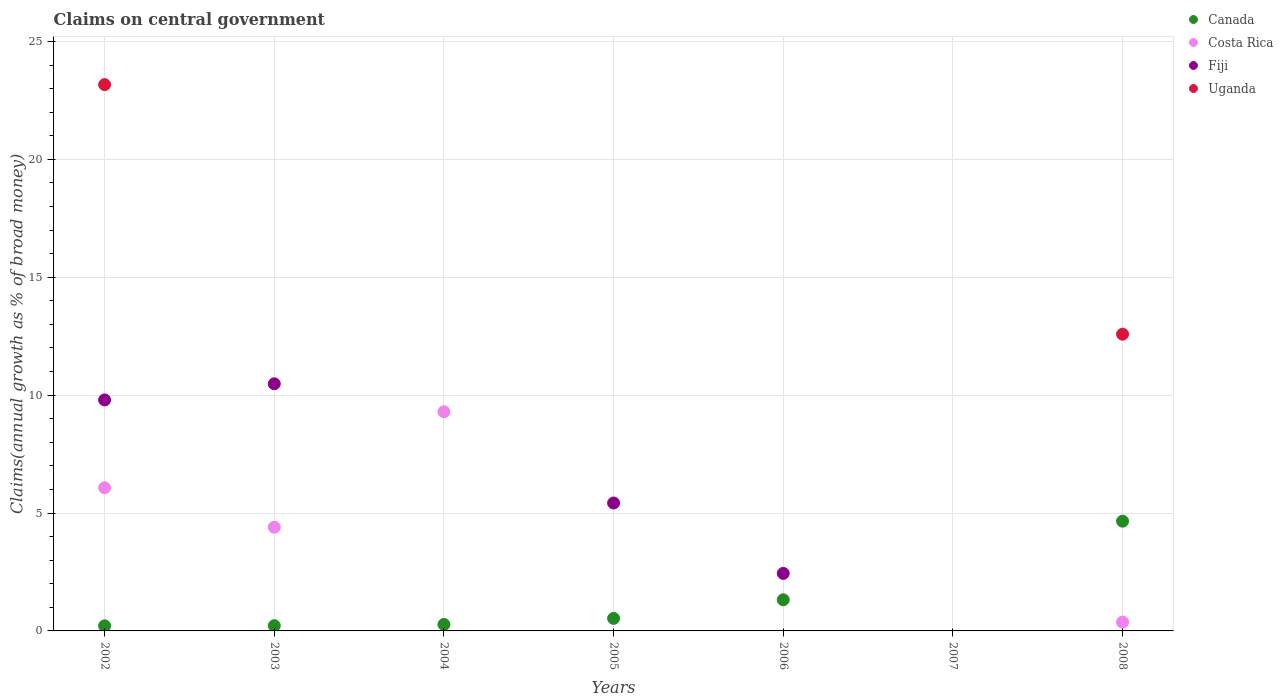How many different coloured dotlines are there?
Offer a very short reply. 4. What is the percentage of broad money claimed on centeral government in Costa Rica in 2003?
Give a very brief answer. 4.4. Across all years, what is the maximum percentage of broad money claimed on centeral government in Canada?
Your answer should be very brief. 4.65. In which year was the percentage of broad money claimed on centeral government in Uganda maximum?
Your answer should be compact. 2002. What is the total percentage of broad money claimed on centeral government in Fiji in the graph?
Keep it short and to the point. 28.14. What is the difference between the percentage of broad money claimed on centeral government in Canada in 2004 and that in 2005?
Your answer should be compact. -0.26. What is the difference between the percentage of broad money claimed on centeral government in Canada in 2006 and the percentage of broad money claimed on centeral government in Costa Rica in 2005?
Your response must be concise. 1.32. What is the average percentage of broad money claimed on centeral government in Fiji per year?
Give a very brief answer. 4.02. In the year 2002, what is the difference between the percentage of broad money claimed on centeral government in Fiji and percentage of broad money claimed on centeral government in Costa Rica?
Offer a very short reply. 3.73. In how many years, is the percentage of broad money claimed on centeral government in Fiji greater than 4 %?
Ensure brevity in your answer.  3. What is the ratio of the percentage of broad money claimed on centeral government in Fiji in 2003 to that in 2006?
Offer a very short reply. 4.3. What is the difference between the highest and the second highest percentage of broad money claimed on centeral government in Canada?
Ensure brevity in your answer.  3.33. What is the difference between the highest and the lowest percentage of broad money claimed on centeral government in Uganda?
Keep it short and to the point. 23.17. Is it the case that in every year, the sum of the percentage of broad money claimed on centeral government in Fiji and percentage of broad money claimed on centeral government in Costa Rica  is greater than the sum of percentage of broad money claimed on centeral government in Uganda and percentage of broad money claimed on centeral government in Canada?
Ensure brevity in your answer.  No. How many years are there in the graph?
Your answer should be very brief. 7. Are the values on the major ticks of Y-axis written in scientific E-notation?
Your response must be concise. No. Does the graph contain any zero values?
Provide a succinct answer. Yes. Does the graph contain grids?
Keep it short and to the point. Yes. Where does the legend appear in the graph?
Keep it short and to the point. Top right. How are the legend labels stacked?
Make the answer very short. Vertical. What is the title of the graph?
Provide a succinct answer. Claims on central government. What is the label or title of the Y-axis?
Provide a succinct answer. Claims(annual growth as % of broad money). What is the Claims(annual growth as % of broad money) in Canada in 2002?
Your answer should be very brief. 0.22. What is the Claims(annual growth as % of broad money) of Costa Rica in 2002?
Your answer should be compact. 6.07. What is the Claims(annual growth as % of broad money) of Fiji in 2002?
Offer a terse response. 9.8. What is the Claims(annual growth as % of broad money) of Uganda in 2002?
Your response must be concise. 23.17. What is the Claims(annual growth as % of broad money) in Canada in 2003?
Offer a terse response. 0.22. What is the Claims(annual growth as % of broad money) in Costa Rica in 2003?
Your answer should be compact. 4.4. What is the Claims(annual growth as % of broad money) of Fiji in 2003?
Your response must be concise. 10.48. What is the Claims(annual growth as % of broad money) in Canada in 2004?
Your answer should be very brief. 0.27. What is the Claims(annual growth as % of broad money) of Costa Rica in 2004?
Your response must be concise. 9.3. What is the Claims(annual growth as % of broad money) in Uganda in 2004?
Provide a short and direct response. 0. What is the Claims(annual growth as % of broad money) in Canada in 2005?
Offer a very short reply. 0.53. What is the Claims(annual growth as % of broad money) of Costa Rica in 2005?
Offer a very short reply. 0. What is the Claims(annual growth as % of broad money) in Fiji in 2005?
Your answer should be very brief. 5.42. What is the Claims(annual growth as % of broad money) of Uganda in 2005?
Your response must be concise. 0. What is the Claims(annual growth as % of broad money) in Canada in 2006?
Offer a terse response. 1.32. What is the Claims(annual growth as % of broad money) in Costa Rica in 2006?
Your answer should be compact. 0. What is the Claims(annual growth as % of broad money) of Fiji in 2006?
Offer a terse response. 2.44. What is the Claims(annual growth as % of broad money) of Uganda in 2006?
Your answer should be very brief. 0. What is the Claims(annual growth as % of broad money) in Costa Rica in 2007?
Make the answer very short. 0. What is the Claims(annual growth as % of broad money) of Canada in 2008?
Your answer should be very brief. 4.65. What is the Claims(annual growth as % of broad money) in Costa Rica in 2008?
Provide a short and direct response. 0.38. What is the Claims(annual growth as % of broad money) of Fiji in 2008?
Provide a succinct answer. 0. What is the Claims(annual growth as % of broad money) in Uganda in 2008?
Your answer should be compact. 12.59. Across all years, what is the maximum Claims(annual growth as % of broad money) in Canada?
Keep it short and to the point. 4.65. Across all years, what is the maximum Claims(annual growth as % of broad money) of Costa Rica?
Give a very brief answer. 9.3. Across all years, what is the maximum Claims(annual growth as % of broad money) of Fiji?
Offer a very short reply. 10.48. Across all years, what is the maximum Claims(annual growth as % of broad money) in Uganda?
Offer a very short reply. 23.17. Across all years, what is the minimum Claims(annual growth as % of broad money) in Canada?
Offer a terse response. 0. Across all years, what is the minimum Claims(annual growth as % of broad money) in Fiji?
Provide a succinct answer. 0. What is the total Claims(annual growth as % of broad money) in Canada in the graph?
Provide a succinct answer. 7.22. What is the total Claims(annual growth as % of broad money) in Costa Rica in the graph?
Provide a succinct answer. 20.14. What is the total Claims(annual growth as % of broad money) in Fiji in the graph?
Offer a very short reply. 28.14. What is the total Claims(annual growth as % of broad money) of Uganda in the graph?
Give a very brief answer. 35.76. What is the difference between the Claims(annual growth as % of broad money) in Canada in 2002 and that in 2003?
Ensure brevity in your answer.  -0.01. What is the difference between the Claims(annual growth as % of broad money) of Costa Rica in 2002 and that in 2003?
Offer a very short reply. 1.67. What is the difference between the Claims(annual growth as % of broad money) of Fiji in 2002 and that in 2003?
Your response must be concise. -0.68. What is the difference between the Claims(annual growth as % of broad money) in Canada in 2002 and that in 2004?
Offer a terse response. -0.06. What is the difference between the Claims(annual growth as % of broad money) of Costa Rica in 2002 and that in 2004?
Keep it short and to the point. -3.22. What is the difference between the Claims(annual growth as % of broad money) in Canada in 2002 and that in 2005?
Your answer should be very brief. -0.32. What is the difference between the Claims(annual growth as % of broad money) in Fiji in 2002 and that in 2005?
Your answer should be very brief. 4.37. What is the difference between the Claims(annual growth as % of broad money) in Canada in 2002 and that in 2006?
Your response must be concise. -1.1. What is the difference between the Claims(annual growth as % of broad money) in Fiji in 2002 and that in 2006?
Keep it short and to the point. 7.36. What is the difference between the Claims(annual growth as % of broad money) in Canada in 2002 and that in 2008?
Your answer should be very brief. -4.44. What is the difference between the Claims(annual growth as % of broad money) of Costa Rica in 2002 and that in 2008?
Your response must be concise. 5.7. What is the difference between the Claims(annual growth as % of broad money) of Uganda in 2002 and that in 2008?
Give a very brief answer. 10.59. What is the difference between the Claims(annual growth as % of broad money) of Canada in 2003 and that in 2004?
Offer a very short reply. -0.05. What is the difference between the Claims(annual growth as % of broad money) of Costa Rica in 2003 and that in 2004?
Offer a very short reply. -4.9. What is the difference between the Claims(annual growth as % of broad money) in Canada in 2003 and that in 2005?
Your answer should be compact. -0.31. What is the difference between the Claims(annual growth as % of broad money) in Fiji in 2003 and that in 2005?
Provide a short and direct response. 5.06. What is the difference between the Claims(annual growth as % of broad money) in Canada in 2003 and that in 2006?
Your response must be concise. -1.1. What is the difference between the Claims(annual growth as % of broad money) in Fiji in 2003 and that in 2006?
Ensure brevity in your answer.  8.04. What is the difference between the Claims(annual growth as % of broad money) in Canada in 2003 and that in 2008?
Your answer should be compact. -4.43. What is the difference between the Claims(annual growth as % of broad money) of Costa Rica in 2003 and that in 2008?
Give a very brief answer. 4.02. What is the difference between the Claims(annual growth as % of broad money) of Canada in 2004 and that in 2005?
Provide a succinct answer. -0.26. What is the difference between the Claims(annual growth as % of broad money) of Canada in 2004 and that in 2006?
Give a very brief answer. -1.05. What is the difference between the Claims(annual growth as % of broad money) in Canada in 2004 and that in 2008?
Provide a succinct answer. -4.38. What is the difference between the Claims(annual growth as % of broad money) in Costa Rica in 2004 and that in 2008?
Offer a very short reply. 8.92. What is the difference between the Claims(annual growth as % of broad money) of Canada in 2005 and that in 2006?
Provide a short and direct response. -0.79. What is the difference between the Claims(annual growth as % of broad money) of Fiji in 2005 and that in 2006?
Ensure brevity in your answer.  2.99. What is the difference between the Claims(annual growth as % of broad money) of Canada in 2005 and that in 2008?
Your answer should be very brief. -4.12. What is the difference between the Claims(annual growth as % of broad money) of Canada in 2006 and that in 2008?
Provide a succinct answer. -3.33. What is the difference between the Claims(annual growth as % of broad money) of Canada in 2002 and the Claims(annual growth as % of broad money) of Costa Rica in 2003?
Provide a succinct answer. -4.18. What is the difference between the Claims(annual growth as % of broad money) in Canada in 2002 and the Claims(annual growth as % of broad money) in Fiji in 2003?
Give a very brief answer. -10.27. What is the difference between the Claims(annual growth as % of broad money) in Costa Rica in 2002 and the Claims(annual growth as % of broad money) in Fiji in 2003?
Give a very brief answer. -4.41. What is the difference between the Claims(annual growth as % of broad money) in Canada in 2002 and the Claims(annual growth as % of broad money) in Costa Rica in 2004?
Ensure brevity in your answer.  -9.08. What is the difference between the Claims(annual growth as % of broad money) of Canada in 2002 and the Claims(annual growth as % of broad money) of Fiji in 2005?
Give a very brief answer. -5.21. What is the difference between the Claims(annual growth as % of broad money) in Costa Rica in 2002 and the Claims(annual growth as % of broad money) in Fiji in 2005?
Your response must be concise. 0.65. What is the difference between the Claims(annual growth as % of broad money) in Canada in 2002 and the Claims(annual growth as % of broad money) in Fiji in 2006?
Your response must be concise. -2.22. What is the difference between the Claims(annual growth as % of broad money) in Costa Rica in 2002 and the Claims(annual growth as % of broad money) in Fiji in 2006?
Provide a succinct answer. 3.63. What is the difference between the Claims(annual growth as % of broad money) in Canada in 2002 and the Claims(annual growth as % of broad money) in Costa Rica in 2008?
Keep it short and to the point. -0.16. What is the difference between the Claims(annual growth as % of broad money) in Canada in 2002 and the Claims(annual growth as % of broad money) in Uganda in 2008?
Make the answer very short. -12.37. What is the difference between the Claims(annual growth as % of broad money) of Costa Rica in 2002 and the Claims(annual growth as % of broad money) of Uganda in 2008?
Ensure brevity in your answer.  -6.51. What is the difference between the Claims(annual growth as % of broad money) of Fiji in 2002 and the Claims(annual growth as % of broad money) of Uganda in 2008?
Your response must be concise. -2.79. What is the difference between the Claims(annual growth as % of broad money) in Canada in 2003 and the Claims(annual growth as % of broad money) in Costa Rica in 2004?
Your answer should be compact. -9.07. What is the difference between the Claims(annual growth as % of broad money) of Canada in 2003 and the Claims(annual growth as % of broad money) of Fiji in 2005?
Provide a succinct answer. -5.2. What is the difference between the Claims(annual growth as % of broad money) of Costa Rica in 2003 and the Claims(annual growth as % of broad money) of Fiji in 2005?
Ensure brevity in your answer.  -1.03. What is the difference between the Claims(annual growth as % of broad money) of Canada in 2003 and the Claims(annual growth as % of broad money) of Fiji in 2006?
Give a very brief answer. -2.22. What is the difference between the Claims(annual growth as % of broad money) in Costa Rica in 2003 and the Claims(annual growth as % of broad money) in Fiji in 2006?
Offer a very short reply. 1.96. What is the difference between the Claims(annual growth as % of broad money) of Canada in 2003 and the Claims(annual growth as % of broad money) of Costa Rica in 2008?
Your answer should be compact. -0.15. What is the difference between the Claims(annual growth as % of broad money) in Canada in 2003 and the Claims(annual growth as % of broad money) in Uganda in 2008?
Ensure brevity in your answer.  -12.36. What is the difference between the Claims(annual growth as % of broad money) of Costa Rica in 2003 and the Claims(annual growth as % of broad money) of Uganda in 2008?
Your answer should be compact. -8.19. What is the difference between the Claims(annual growth as % of broad money) in Fiji in 2003 and the Claims(annual growth as % of broad money) in Uganda in 2008?
Offer a terse response. -2.1. What is the difference between the Claims(annual growth as % of broad money) in Canada in 2004 and the Claims(annual growth as % of broad money) in Fiji in 2005?
Offer a terse response. -5.15. What is the difference between the Claims(annual growth as % of broad money) of Costa Rica in 2004 and the Claims(annual growth as % of broad money) of Fiji in 2005?
Your response must be concise. 3.87. What is the difference between the Claims(annual growth as % of broad money) of Canada in 2004 and the Claims(annual growth as % of broad money) of Fiji in 2006?
Offer a very short reply. -2.16. What is the difference between the Claims(annual growth as % of broad money) of Costa Rica in 2004 and the Claims(annual growth as % of broad money) of Fiji in 2006?
Your answer should be compact. 6.86. What is the difference between the Claims(annual growth as % of broad money) in Canada in 2004 and the Claims(annual growth as % of broad money) in Costa Rica in 2008?
Offer a very short reply. -0.1. What is the difference between the Claims(annual growth as % of broad money) of Canada in 2004 and the Claims(annual growth as % of broad money) of Uganda in 2008?
Give a very brief answer. -12.31. What is the difference between the Claims(annual growth as % of broad money) in Costa Rica in 2004 and the Claims(annual growth as % of broad money) in Uganda in 2008?
Your answer should be very brief. -3.29. What is the difference between the Claims(annual growth as % of broad money) of Canada in 2005 and the Claims(annual growth as % of broad money) of Fiji in 2006?
Offer a terse response. -1.91. What is the difference between the Claims(annual growth as % of broad money) in Canada in 2005 and the Claims(annual growth as % of broad money) in Costa Rica in 2008?
Give a very brief answer. 0.16. What is the difference between the Claims(annual growth as % of broad money) in Canada in 2005 and the Claims(annual growth as % of broad money) in Uganda in 2008?
Make the answer very short. -12.05. What is the difference between the Claims(annual growth as % of broad money) of Fiji in 2005 and the Claims(annual growth as % of broad money) of Uganda in 2008?
Make the answer very short. -7.16. What is the difference between the Claims(annual growth as % of broad money) in Canada in 2006 and the Claims(annual growth as % of broad money) in Costa Rica in 2008?
Offer a very short reply. 0.95. What is the difference between the Claims(annual growth as % of broad money) of Canada in 2006 and the Claims(annual growth as % of broad money) of Uganda in 2008?
Offer a terse response. -11.26. What is the difference between the Claims(annual growth as % of broad money) in Fiji in 2006 and the Claims(annual growth as % of broad money) in Uganda in 2008?
Your response must be concise. -10.15. What is the average Claims(annual growth as % of broad money) of Canada per year?
Offer a very short reply. 1.03. What is the average Claims(annual growth as % of broad money) of Costa Rica per year?
Your answer should be very brief. 2.88. What is the average Claims(annual growth as % of broad money) in Fiji per year?
Your answer should be very brief. 4.02. What is the average Claims(annual growth as % of broad money) in Uganda per year?
Offer a terse response. 5.11. In the year 2002, what is the difference between the Claims(annual growth as % of broad money) of Canada and Claims(annual growth as % of broad money) of Costa Rica?
Offer a terse response. -5.86. In the year 2002, what is the difference between the Claims(annual growth as % of broad money) in Canada and Claims(annual growth as % of broad money) in Fiji?
Your answer should be very brief. -9.58. In the year 2002, what is the difference between the Claims(annual growth as % of broad money) of Canada and Claims(annual growth as % of broad money) of Uganda?
Give a very brief answer. -22.95. In the year 2002, what is the difference between the Claims(annual growth as % of broad money) in Costa Rica and Claims(annual growth as % of broad money) in Fiji?
Give a very brief answer. -3.73. In the year 2002, what is the difference between the Claims(annual growth as % of broad money) of Costa Rica and Claims(annual growth as % of broad money) of Uganda?
Provide a short and direct response. -17.1. In the year 2002, what is the difference between the Claims(annual growth as % of broad money) in Fiji and Claims(annual growth as % of broad money) in Uganda?
Ensure brevity in your answer.  -13.37. In the year 2003, what is the difference between the Claims(annual growth as % of broad money) in Canada and Claims(annual growth as % of broad money) in Costa Rica?
Keep it short and to the point. -4.18. In the year 2003, what is the difference between the Claims(annual growth as % of broad money) in Canada and Claims(annual growth as % of broad money) in Fiji?
Provide a short and direct response. -10.26. In the year 2003, what is the difference between the Claims(annual growth as % of broad money) of Costa Rica and Claims(annual growth as % of broad money) of Fiji?
Your answer should be compact. -6.08. In the year 2004, what is the difference between the Claims(annual growth as % of broad money) of Canada and Claims(annual growth as % of broad money) of Costa Rica?
Provide a succinct answer. -9.02. In the year 2005, what is the difference between the Claims(annual growth as % of broad money) of Canada and Claims(annual growth as % of broad money) of Fiji?
Offer a terse response. -4.89. In the year 2006, what is the difference between the Claims(annual growth as % of broad money) of Canada and Claims(annual growth as % of broad money) of Fiji?
Offer a terse response. -1.12. In the year 2008, what is the difference between the Claims(annual growth as % of broad money) in Canada and Claims(annual growth as % of broad money) in Costa Rica?
Keep it short and to the point. 4.28. In the year 2008, what is the difference between the Claims(annual growth as % of broad money) in Canada and Claims(annual growth as % of broad money) in Uganda?
Keep it short and to the point. -7.93. In the year 2008, what is the difference between the Claims(annual growth as % of broad money) in Costa Rica and Claims(annual growth as % of broad money) in Uganda?
Provide a succinct answer. -12.21. What is the ratio of the Claims(annual growth as % of broad money) of Canada in 2002 to that in 2003?
Your response must be concise. 0.98. What is the ratio of the Claims(annual growth as % of broad money) in Costa Rica in 2002 to that in 2003?
Offer a terse response. 1.38. What is the ratio of the Claims(annual growth as % of broad money) of Fiji in 2002 to that in 2003?
Provide a succinct answer. 0.93. What is the ratio of the Claims(annual growth as % of broad money) in Canada in 2002 to that in 2004?
Keep it short and to the point. 0.79. What is the ratio of the Claims(annual growth as % of broad money) of Costa Rica in 2002 to that in 2004?
Give a very brief answer. 0.65. What is the ratio of the Claims(annual growth as % of broad money) of Canada in 2002 to that in 2005?
Your response must be concise. 0.41. What is the ratio of the Claims(annual growth as % of broad money) of Fiji in 2002 to that in 2005?
Give a very brief answer. 1.81. What is the ratio of the Claims(annual growth as % of broad money) in Canada in 2002 to that in 2006?
Offer a very short reply. 0.16. What is the ratio of the Claims(annual growth as % of broad money) of Fiji in 2002 to that in 2006?
Your response must be concise. 4.02. What is the ratio of the Claims(annual growth as % of broad money) in Canada in 2002 to that in 2008?
Make the answer very short. 0.05. What is the ratio of the Claims(annual growth as % of broad money) in Costa Rica in 2002 to that in 2008?
Offer a very short reply. 16.16. What is the ratio of the Claims(annual growth as % of broad money) of Uganda in 2002 to that in 2008?
Provide a short and direct response. 1.84. What is the ratio of the Claims(annual growth as % of broad money) in Canada in 2003 to that in 2004?
Give a very brief answer. 0.81. What is the ratio of the Claims(annual growth as % of broad money) of Costa Rica in 2003 to that in 2004?
Offer a very short reply. 0.47. What is the ratio of the Claims(annual growth as % of broad money) in Canada in 2003 to that in 2005?
Offer a terse response. 0.42. What is the ratio of the Claims(annual growth as % of broad money) in Fiji in 2003 to that in 2005?
Provide a short and direct response. 1.93. What is the ratio of the Claims(annual growth as % of broad money) in Canada in 2003 to that in 2006?
Offer a terse response. 0.17. What is the ratio of the Claims(annual growth as % of broad money) of Fiji in 2003 to that in 2006?
Keep it short and to the point. 4.3. What is the ratio of the Claims(annual growth as % of broad money) of Canada in 2003 to that in 2008?
Ensure brevity in your answer.  0.05. What is the ratio of the Claims(annual growth as % of broad money) of Costa Rica in 2003 to that in 2008?
Offer a terse response. 11.71. What is the ratio of the Claims(annual growth as % of broad money) of Canada in 2004 to that in 2005?
Your answer should be very brief. 0.52. What is the ratio of the Claims(annual growth as % of broad money) in Canada in 2004 to that in 2006?
Your answer should be very brief. 0.21. What is the ratio of the Claims(annual growth as % of broad money) in Canada in 2004 to that in 2008?
Give a very brief answer. 0.06. What is the ratio of the Claims(annual growth as % of broad money) in Costa Rica in 2004 to that in 2008?
Make the answer very short. 24.74. What is the ratio of the Claims(annual growth as % of broad money) of Canada in 2005 to that in 2006?
Your answer should be compact. 0.4. What is the ratio of the Claims(annual growth as % of broad money) of Fiji in 2005 to that in 2006?
Provide a short and direct response. 2.22. What is the ratio of the Claims(annual growth as % of broad money) of Canada in 2005 to that in 2008?
Ensure brevity in your answer.  0.11. What is the ratio of the Claims(annual growth as % of broad money) in Canada in 2006 to that in 2008?
Give a very brief answer. 0.28. What is the difference between the highest and the second highest Claims(annual growth as % of broad money) of Canada?
Your answer should be compact. 3.33. What is the difference between the highest and the second highest Claims(annual growth as % of broad money) in Costa Rica?
Ensure brevity in your answer.  3.22. What is the difference between the highest and the second highest Claims(annual growth as % of broad money) of Fiji?
Offer a terse response. 0.68. What is the difference between the highest and the lowest Claims(annual growth as % of broad money) in Canada?
Provide a succinct answer. 4.66. What is the difference between the highest and the lowest Claims(annual growth as % of broad money) of Costa Rica?
Keep it short and to the point. 9.3. What is the difference between the highest and the lowest Claims(annual growth as % of broad money) of Fiji?
Make the answer very short. 10.48. What is the difference between the highest and the lowest Claims(annual growth as % of broad money) of Uganda?
Ensure brevity in your answer.  23.17. 